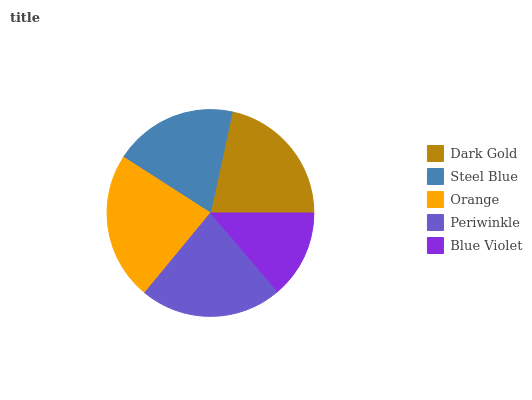Is Blue Violet the minimum?
Answer yes or no. Yes. Is Orange the maximum?
Answer yes or no. Yes. Is Steel Blue the minimum?
Answer yes or no. No. Is Steel Blue the maximum?
Answer yes or no. No. Is Dark Gold greater than Steel Blue?
Answer yes or no. Yes. Is Steel Blue less than Dark Gold?
Answer yes or no. Yes. Is Steel Blue greater than Dark Gold?
Answer yes or no. No. Is Dark Gold less than Steel Blue?
Answer yes or no. No. Is Dark Gold the high median?
Answer yes or no. Yes. Is Dark Gold the low median?
Answer yes or no. Yes. Is Orange the high median?
Answer yes or no. No. Is Periwinkle the low median?
Answer yes or no. No. 